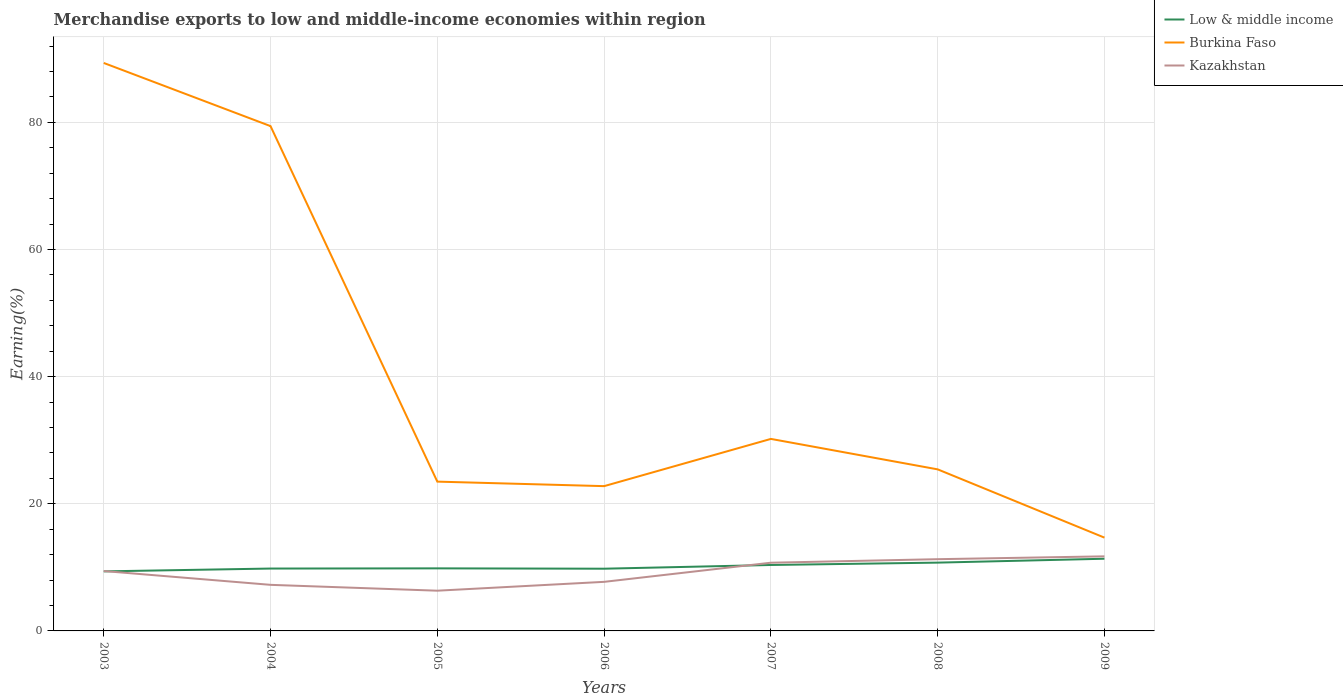Across all years, what is the maximum percentage of amount earned from merchandise exports in Burkina Faso?
Give a very brief answer. 14.67. In which year was the percentage of amount earned from merchandise exports in Low & middle income maximum?
Your answer should be compact. 2003. What is the total percentage of amount earned from merchandise exports in Burkina Faso in the graph?
Your answer should be very brief. 4.79. What is the difference between the highest and the second highest percentage of amount earned from merchandise exports in Low & middle income?
Your answer should be very brief. 1.99. What is the difference between the highest and the lowest percentage of amount earned from merchandise exports in Burkina Faso?
Your response must be concise. 2. Is the percentage of amount earned from merchandise exports in Burkina Faso strictly greater than the percentage of amount earned from merchandise exports in Low & middle income over the years?
Your response must be concise. No. How many lines are there?
Your response must be concise. 3. What is the difference between two consecutive major ticks on the Y-axis?
Your response must be concise. 20. Are the values on the major ticks of Y-axis written in scientific E-notation?
Ensure brevity in your answer.  No. Where does the legend appear in the graph?
Make the answer very short. Top right. How are the legend labels stacked?
Keep it short and to the point. Vertical. What is the title of the graph?
Keep it short and to the point. Merchandise exports to low and middle-income economies within region. Does "Korea (Republic)" appear as one of the legend labels in the graph?
Provide a short and direct response. No. What is the label or title of the X-axis?
Offer a terse response. Years. What is the label or title of the Y-axis?
Provide a short and direct response. Earning(%). What is the Earning(%) in Low & middle income in 2003?
Offer a terse response. 9.37. What is the Earning(%) in Burkina Faso in 2003?
Your answer should be compact. 89.34. What is the Earning(%) in Kazakhstan in 2003?
Your answer should be compact. 9.42. What is the Earning(%) of Low & middle income in 2004?
Offer a terse response. 9.81. What is the Earning(%) in Burkina Faso in 2004?
Make the answer very short. 79.41. What is the Earning(%) in Kazakhstan in 2004?
Ensure brevity in your answer.  7.25. What is the Earning(%) of Low & middle income in 2005?
Provide a succinct answer. 9.84. What is the Earning(%) in Burkina Faso in 2005?
Offer a terse response. 23.48. What is the Earning(%) of Kazakhstan in 2005?
Offer a very short reply. 6.33. What is the Earning(%) in Low & middle income in 2006?
Offer a very short reply. 9.79. What is the Earning(%) of Burkina Faso in 2006?
Your answer should be compact. 22.77. What is the Earning(%) of Kazakhstan in 2006?
Keep it short and to the point. 7.72. What is the Earning(%) in Low & middle income in 2007?
Your answer should be very brief. 10.37. What is the Earning(%) of Burkina Faso in 2007?
Your response must be concise. 30.2. What is the Earning(%) of Kazakhstan in 2007?
Provide a short and direct response. 10.73. What is the Earning(%) of Low & middle income in 2008?
Give a very brief answer. 10.74. What is the Earning(%) in Burkina Faso in 2008?
Your answer should be compact. 25.41. What is the Earning(%) in Kazakhstan in 2008?
Give a very brief answer. 11.28. What is the Earning(%) of Low & middle income in 2009?
Your answer should be very brief. 11.35. What is the Earning(%) of Burkina Faso in 2009?
Give a very brief answer. 14.67. What is the Earning(%) in Kazakhstan in 2009?
Your response must be concise. 11.73. Across all years, what is the maximum Earning(%) of Low & middle income?
Your response must be concise. 11.35. Across all years, what is the maximum Earning(%) in Burkina Faso?
Your answer should be compact. 89.34. Across all years, what is the maximum Earning(%) of Kazakhstan?
Your answer should be very brief. 11.73. Across all years, what is the minimum Earning(%) in Low & middle income?
Your response must be concise. 9.37. Across all years, what is the minimum Earning(%) in Burkina Faso?
Offer a terse response. 14.67. Across all years, what is the minimum Earning(%) in Kazakhstan?
Provide a short and direct response. 6.33. What is the total Earning(%) in Low & middle income in the graph?
Your answer should be compact. 71.28. What is the total Earning(%) of Burkina Faso in the graph?
Provide a succinct answer. 285.3. What is the total Earning(%) in Kazakhstan in the graph?
Give a very brief answer. 64.46. What is the difference between the Earning(%) in Low & middle income in 2003 and that in 2004?
Offer a terse response. -0.44. What is the difference between the Earning(%) of Burkina Faso in 2003 and that in 2004?
Ensure brevity in your answer.  9.93. What is the difference between the Earning(%) in Kazakhstan in 2003 and that in 2004?
Your answer should be very brief. 2.17. What is the difference between the Earning(%) of Low & middle income in 2003 and that in 2005?
Offer a terse response. -0.47. What is the difference between the Earning(%) of Burkina Faso in 2003 and that in 2005?
Your response must be concise. 65.86. What is the difference between the Earning(%) of Kazakhstan in 2003 and that in 2005?
Your response must be concise. 3.09. What is the difference between the Earning(%) in Low & middle income in 2003 and that in 2006?
Give a very brief answer. -0.42. What is the difference between the Earning(%) in Burkina Faso in 2003 and that in 2006?
Your response must be concise. 66.57. What is the difference between the Earning(%) in Kazakhstan in 2003 and that in 2006?
Make the answer very short. 1.7. What is the difference between the Earning(%) of Low & middle income in 2003 and that in 2007?
Offer a very short reply. -1.01. What is the difference between the Earning(%) in Burkina Faso in 2003 and that in 2007?
Provide a short and direct response. 59.14. What is the difference between the Earning(%) in Kazakhstan in 2003 and that in 2007?
Ensure brevity in your answer.  -1.31. What is the difference between the Earning(%) of Low & middle income in 2003 and that in 2008?
Keep it short and to the point. -1.38. What is the difference between the Earning(%) in Burkina Faso in 2003 and that in 2008?
Offer a very short reply. 63.92. What is the difference between the Earning(%) of Kazakhstan in 2003 and that in 2008?
Provide a short and direct response. -1.86. What is the difference between the Earning(%) of Low & middle income in 2003 and that in 2009?
Provide a short and direct response. -1.99. What is the difference between the Earning(%) in Burkina Faso in 2003 and that in 2009?
Make the answer very short. 74.66. What is the difference between the Earning(%) in Kazakhstan in 2003 and that in 2009?
Ensure brevity in your answer.  -2.31. What is the difference between the Earning(%) of Low & middle income in 2004 and that in 2005?
Your response must be concise. -0.03. What is the difference between the Earning(%) of Burkina Faso in 2004 and that in 2005?
Offer a terse response. 55.92. What is the difference between the Earning(%) in Kazakhstan in 2004 and that in 2005?
Provide a short and direct response. 0.92. What is the difference between the Earning(%) in Low & middle income in 2004 and that in 2006?
Your answer should be compact. 0.02. What is the difference between the Earning(%) of Burkina Faso in 2004 and that in 2006?
Offer a very short reply. 56.63. What is the difference between the Earning(%) in Kazakhstan in 2004 and that in 2006?
Offer a terse response. -0.47. What is the difference between the Earning(%) of Low & middle income in 2004 and that in 2007?
Ensure brevity in your answer.  -0.56. What is the difference between the Earning(%) of Burkina Faso in 2004 and that in 2007?
Provide a short and direct response. 49.2. What is the difference between the Earning(%) of Kazakhstan in 2004 and that in 2007?
Your response must be concise. -3.48. What is the difference between the Earning(%) of Low & middle income in 2004 and that in 2008?
Offer a terse response. -0.93. What is the difference between the Earning(%) in Burkina Faso in 2004 and that in 2008?
Your response must be concise. 53.99. What is the difference between the Earning(%) of Kazakhstan in 2004 and that in 2008?
Ensure brevity in your answer.  -4.04. What is the difference between the Earning(%) in Low & middle income in 2004 and that in 2009?
Provide a short and direct response. -1.54. What is the difference between the Earning(%) in Burkina Faso in 2004 and that in 2009?
Keep it short and to the point. 64.73. What is the difference between the Earning(%) of Kazakhstan in 2004 and that in 2009?
Give a very brief answer. -4.48. What is the difference between the Earning(%) of Low & middle income in 2005 and that in 2006?
Offer a very short reply. 0.05. What is the difference between the Earning(%) of Burkina Faso in 2005 and that in 2006?
Give a very brief answer. 0.71. What is the difference between the Earning(%) in Kazakhstan in 2005 and that in 2006?
Offer a very short reply. -1.39. What is the difference between the Earning(%) of Low & middle income in 2005 and that in 2007?
Your response must be concise. -0.53. What is the difference between the Earning(%) of Burkina Faso in 2005 and that in 2007?
Provide a short and direct response. -6.72. What is the difference between the Earning(%) in Kazakhstan in 2005 and that in 2007?
Provide a short and direct response. -4.4. What is the difference between the Earning(%) in Low & middle income in 2005 and that in 2008?
Ensure brevity in your answer.  -0.9. What is the difference between the Earning(%) of Burkina Faso in 2005 and that in 2008?
Ensure brevity in your answer.  -1.93. What is the difference between the Earning(%) of Kazakhstan in 2005 and that in 2008?
Provide a short and direct response. -4.96. What is the difference between the Earning(%) of Low & middle income in 2005 and that in 2009?
Your response must be concise. -1.51. What is the difference between the Earning(%) in Burkina Faso in 2005 and that in 2009?
Offer a very short reply. 8.81. What is the difference between the Earning(%) of Kazakhstan in 2005 and that in 2009?
Give a very brief answer. -5.4. What is the difference between the Earning(%) of Low & middle income in 2006 and that in 2007?
Your answer should be compact. -0.59. What is the difference between the Earning(%) of Burkina Faso in 2006 and that in 2007?
Your answer should be very brief. -7.43. What is the difference between the Earning(%) in Kazakhstan in 2006 and that in 2007?
Make the answer very short. -3.01. What is the difference between the Earning(%) of Low & middle income in 2006 and that in 2008?
Your answer should be very brief. -0.96. What is the difference between the Earning(%) of Burkina Faso in 2006 and that in 2008?
Your answer should be very brief. -2.64. What is the difference between the Earning(%) in Kazakhstan in 2006 and that in 2008?
Your response must be concise. -3.56. What is the difference between the Earning(%) in Low & middle income in 2006 and that in 2009?
Keep it short and to the point. -1.57. What is the difference between the Earning(%) in Burkina Faso in 2006 and that in 2009?
Provide a short and direct response. 8.1. What is the difference between the Earning(%) of Kazakhstan in 2006 and that in 2009?
Give a very brief answer. -4.01. What is the difference between the Earning(%) of Low & middle income in 2007 and that in 2008?
Offer a very short reply. -0.37. What is the difference between the Earning(%) of Burkina Faso in 2007 and that in 2008?
Provide a short and direct response. 4.79. What is the difference between the Earning(%) in Kazakhstan in 2007 and that in 2008?
Give a very brief answer. -0.55. What is the difference between the Earning(%) in Low & middle income in 2007 and that in 2009?
Provide a short and direct response. -0.98. What is the difference between the Earning(%) of Burkina Faso in 2007 and that in 2009?
Offer a very short reply. 15.53. What is the difference between the Earning(%) in Kazakhstan in 2007 and that in 2009?
Your answer should be very brief. -1. What is the difference between the Earning(%) of Low & middle income in 2008 and that in 2009?
Make the answer very short. -0.61. What is the difference between the Earning(%) of Burkina Faso in 2008 and that in 2009?
Keep it short and to the point. 10.74. What is the difference between the Earning(%) of Kazakhstan in 2008 and that in 2009?
Offer a terse response. -0.45. What is the difference between the Earning(%) of Low & middle income in 2003 and the Earning(%) of Burkina Faso in 2004?
Ensure brevity in your answer.  -70.04. What is the difference between the Earning(%) in Low & middle income in 2003 and the Earning(%) in Kazakhstan in 2004?
Your response must be concise. 2.12. What is the difference between the Earning(%) in Burkina Faso in 2003 and the Earning(%) in Kazakhstan in 2004?
Your answer should be compact. 82.09. What is the difference between the Earning(%) of Low & middle income in 2003 and the Earning(%) of Burkina Faso in 2005?
Ensure brevity in your answer.  -14.12. What is the difference between the Earning(%) of Low & middle income in 2003 and the Earning(%) of Kazakhstan in 2005?
Offer a terse response. 3.04. What is the difference between the Earning(%) in Burkina Faso in 2003 and the Earning(%) in Kazakhstan in 2005?
Your answer should be very brief. 83.01. What is the difference between the Earning(%) of Low & middle income in 2003 and the Earning(%) of Burkina Faso in 2006?
Provide a succinct answer. -13.41. What is the difference between the Earning(%) of Low & middle income in 2003 and the Earning(%) of Kazakhstan in 2006?
Provide a short and direct response. 1.65. What is the difference between the Earning(%) of Burkina Faso in 2003 and the Earning(%) of Kazakhstan in 2006?
Keep it short and to the point. 81.62. What is the difference between the Earning(%) in Low & middle income in 2003 and the Earning(%) in Burkina Faso in 2007?
Give a very brief answer. -20.84. What is the difference between the Earning(%) of Low & middle income in 2003 and the Earning(%) of Kazakhstan in 2007?
Your answer should be very brief. -1.36. What is the difference between the Earning(%) of Burkina Faso in 2003 and the Earning(%) of Kazakhstan in 2007?
Your response must be concise. 78.61. What is the difference between the Earning(%) of Low & middle income in 2003 and the Earning(%) of Burkina Faso in 2008?
Offer a very short reply. -16.05. What is the difference between the Earning(%) in Low & middle income in 2003 and the Earning(%) in Kazakhstan in 2008?
Offer a very short reply. -1.92. What is the difference between the Earning(%) of Burkina Faso in 2003 and the Earning(%) of Kazakhstan in 2008?
Provide a succinct answer. 78.06. What is the difference between the Earning(%) in Low & middle income in 2003 and the Earning(%) in Burkina Faso in 2009?
Your answer should be very brief. -5.31. What is the difference between the Earning(%) in Low & middle income in 2003 and the Earning(%) in Kazakhstan in 2009?
Your answer should be compact. -2.36. What is the difference between the Earning(%) in Burkina Faso in 2003 and the Earning(%) in Kazakhstan in 2009?
Your answer should be compact. 77.61. What is the difference between the Earning(%) of Low & middle income in 2004 and the Earning(%) of Burkina Faso in 2005?
Your answer should be compact. -13.67. What is the difference between the Earning(%) in Low & middle income in 2004 and the Earning(%) in Kazakhstan in 2005?
Your response must be concise. 3.48. What is the difference between the Earning(%) in Burkina Faso in 2004 and the Earning(%) in Kazakhstan in 2005?
Your response must be concise. 73.08. What is the difference between the Earning(%) in Low & middle income in 2004 and the Earning(%) in Burkina Faso in 2006?
Provide a short and direct response. -12.96. What is the difference between the Earning(%) of Low & middle income in 2004 and the Earning(%) of Kazakhstan in 2006?
Give a very brief answer. 2.09. What is the difference between the Earning(%) in Burkina Faso in 2004 and the Earning(%) in Kazakhstan in 2006?
Give a very brief answer. 71.69. What is the difference between the Earning(%) in Low & middle income in 2004 and the Earning(%) in Burkina Faso in 2007?
Your answer should be compact. -20.39. What is the difference between the Earning(%) of Low & middle income in 2004 and the Earning(%) of Kazakhstan in 2007?
Give a very brief answer. -0.92. What is the difference between the Earning(%) of Burkina Faso in 2004 and the Earning(%) of Kazakhstan in 2007?
Keep it short and to the point. 68.68. What is the difference between the Earning(%) in Low & middle income in 2004 and the Earning(%) in Burkina Faso in 2008?
Provide a succinct answer. -15.6. What is the difference between the Earning(%) in Low & middle income in 2004 and the Earning(%) in Kazakhstan in 2008?
Provide a short and direct response. -1.47. What is the difference between the Earning(%) in Burkina Faso in 2004 and the Earning(%) in Kazakhstan in 2008?
Ensure brevity in your answer.  68.12. What is the difference between the Earning(%) of Low & middle income in 2004 and the Earning(%) of Burkina Faso in 2009?
Make the answer very short. -4.86. What is the difference between the Earning(%) of Low & middle income in 2004 and the Earning(%) of Kazakhstan in 2009?
Make the answer very short. -1.92. What is the difference between the Earning(%) of Burkina Faso in 2004 and the Earning(%) of Kazakhstan in 2009?
Give a very brief answer. 67.67. What is the difference between the Earning(%) in Low & middle income in 2005 and the Earning(%) in Burkina Faso in 2006?
Your response must be concise. -12.93. What is the difference between the Earning(%) of Low & middle income in 2005 and the Earning(%) of Kazakhstan in 2006?
Your response must be concise. 2.12. What is the difference between the Earning(%) in Burkina Faso in 2005 and the Earning(%) in Kazakhstan in 2006?
Offer a terse response. 15.77. What is the difference between the Earning(%) of Low & middle income in 2005 and the Earning(%) of Burkina Faso in 2007?
Make the answer very short. -20.36. What is the difference between the Earning(%) of Low & middle income in 2005 and the Earning(%) of Kazakhstan in 2007?
Give a very brief answer. -0.89. What is the difference between the Earning(%) of Burkina Faso in 2005 and the Earning(%) of Kazakhstan in 2007?
Offer a very short reply. 12.76. What is the difference between the Earning(%) of Low & middle income in 2005 and the Earning(%) of Burkina Faso in 2008?
Give a very brief answer. -15.57. What is the difference between the Earning(%) in Low & middle income in 2005 and the Earning(%) in Kazakhstan in 2008?
Make the answer very short. -1.44. What is the difference between the Earning(%) in Burkina Faso in 2005 and the Earning(%) in Kazakhstan in 2008?
Your answer should be compact. 12.2. What is the difference between the Earning(%) in Low & middle income in 2005 and the Earning(%) in Burkina Faso in 2009?
Ensure brevity in your answer.  -4.83. What is the difference between the Earning(%) of Low & middle income in 2005 and the Earning(%) of Kazakhstan in 2009?
Provide a succinct answer. -1.89. What is the difference between the Earning(%) in Burkina Faso in 2005 and the Earning(%) in Kazakhstan in 2009?
Your answer should be very brief. 11.75. What is the difference between the Earning(%) of Low & middle income in 2006 and the Earning(%) of Burkina Faso in 2007?
Your answer should be compact. -20.42. What is the difference between the Earning(%) of Low & middle income in 2006 and the Earning(%) of Kazakhstan in 2007?
Provide a short and direct response. -0.94. What is the difference between the Earning(%) in Burkina Faso in 2006 and the Earning(%) in Kazakhstan in 2007?
Provide a succinct answer. 12.04. What is the difference between the Earning(%) in Low & middle income in 2006 and the Earning(%) in Burkina Faso in 2008?
Give a very brief answer. -15.63. What is the difference between the Earning(%) in Low & middle income in 2006 and the Earning(%) in Kazakhstan in 2008?
Offer a very short reply. -1.5. What is the difference between the Earning(%) of Burkina Faso in 2006 and the Earning(%) of Kazakhstan in 2008?
Offer a very short reply. 11.49. What is the difference between the Earning(%) in Low & middle income in 2006 and the Earning(%) in Burkina Faso in 2009?
Give a very brief answer. -4.89. What is the difference between the Earning(%) in Low & middle income in 2006 and the Earning(%) in Kazakhstan in 2009?
Your answer should be very brief. -1.94. What is the difference between the Earning(%) in Burkina Faso in 2006 and the Earning(%) in Kazakhstan in 2009?
Keep it short and to the point. 11.04. What is the difference between the Earning(%) in Low & middle income in 2007 and the Earning(%) in Burkina Faso in 2008?
Make the answer very short. -15.04. What is the difference between the Earning(%) of Low & middle income in 2007 and the Earning(%) of Kazakhstan in 2008?
Your response must be concise. -0.91. What is the difference between the Earning(%) of Burkina Faso in 2007 and the Earning(%) of Kazakhstan in 2008?
Give a very brief answer. 18.92. What is the difference between the Earning(%) of Low & middle income in 2007 and the Earning(%) of Burkina Faso in 2009?
Provide a short and direct response. -4.3. What is the difference between the Earning(%) of Low & middle income in 2007 and the Earning(%) of Kazakhstan in 2009?
Your answer should be very brief. -1.36. What is the difference between the Earning(%) of Burkina Faso in 2007 and the Earning(%) of Kazakhstan in 2009?
Make the answer very short. 18.47. What is the difference between the Earning(%) in Low & middle income in 2008 and the Earning(%) in Burkina Faso in 2009?
Your response must be concise. -3.93. What is the difference between the Earning(%) of Low & middle income in 2008 and the Earning(%) of Kazakhstan in 2009?
Your response must be concise. -0.99. What is the difference between the Earning(%) in Burkina Faso in 2008 and the Earning(%) in Kazakhstan in 2009?
Provide a succinct answer. 13.68. What is the average Earning(%) in Low & middle income per year?
Keep it short and to the point. 10.18. What is the average Earning(%) of Burkina Faso per year?
Keep it short and to the point. 40.76. What is the average Earning(%) in Kazakhstan per year?
Make the answer very short. 9.21. In the year 2003, what is the difference between the Earning(%) in Low & middle income and Earning(%) in Burkina Faso?
Offer a very short reply. -79.97. In the year 2003, what is the difference between the Earning(%) of Low & middle income and Earning(%) of Kazakhstan?
Your answer should be compact. -0.05. In the year 2003, what is the difference between the Earning(%) of Burkina Faso and Earning(%) of Kazakhstan?
Keep it short and to the point. 79.92. In the year 2004, what is the difference between the Earning(%) of Low & middle income and Earning(%) of Burkina Faso?
Provide a short and direct response. -69.59. In the year 2004, what is the difference between the Earning(%) in Low & middle income and Earning(%) in Kazakhstan?
Offer a very short reply. 2.56. In the year 2004, what is the difference between the Earning(%) in Burkina Faso and Earning(%) in Kazakhstan?
Provide a short and direct response. 72.16. In the year 2005, what is the difference between the Earning(%) in Low & middle income and Earning(%) in Burkina Faso?
Your answer should be compact. -13.64. In the year 2005, what is the difference between the Earning(%) of Low & middle income and Earning(%) of Kazakhstan?
Make the answer very short. 3.51. In the year 2005, what is the difference between the Earning(%) in Burkina Faso and Earning(%) in Kazakhstan?
Your answer should be compact. 17.16. In the year 2006, what is the difference between the Earning(%) of Low & middle income and Earning(%) of Burkina Faso?
Your answer should be very brief. -12.99. In the year 2006, what is the difference between the Earning(%) of Low & middle income and Earning(%) of Kazakhstan?
Ensure brevity in your answer.  2.07. In the year 2006, what is the difference between the Earning(%) of Burkina Faso and Earning(%) of Kazakhstan?
Your response must be concise. 15.05. In the year 2007, what is the difference between the Earning(%) of Low & middle income and Earning(%) of Burkina Faso?
Make the answer very short. -19.83. In the year 2007, what is the difference between the Earning(%) in Low & middle income and Earning(%) in Kazakhstan?
Make the answer very short. -0.36. In the year 2007, what is the difference between the Earning(%) of Burkina Faso and Earning(%) of Kazakhstan?
Make the answer very short. 19.47. In the year 2008, what is the difference between the Earning(%) in Low & middle income and Earning(%) in Burkina Faso?
Keep it short and to the point. -14.67. In the year 2008, what is the difference between the Earning(%) of Low & middle income and Earning(%) of Kazakhstan?
Give a very brief answer. -0.54. In the year 2008, what is the difference between the Earning(%) of Burkina Faso and Earning(%) of Kazakhstan?
Give a very brief answer. 14.13. In the year 2009, what is the difference between the Earning(%) of Low & middle income and Earning(%) of Burkina Faso?
Offer a very short reply. -3.32. In the year 2009, what is the difference between the Earning(%) of Low & middle income and Earning(%) of Kazakhstan?
Offer a very short reply. -0.38. In the year 2009, what is the difference between the Earning(%) of Burkina Faso and Earning(%) of Kazakhstan?
Make the answer very short. 2.94. What is the ratio of the Earning(%) of Low & middle income in 2003 to that in 2004?
Keep it short and to the point. 0.95. What is the ratio of the Earning(%) in Burkina Faso in 2003 to that in 2004?
Offer a very short reply. 1.13. What is the ratio of the Earning(%) in Kazakhstan in 2003 to that in 2004?
Your response must be concise. 1.3. What is the ratio of the Earning(%) in Low & middle income in 2003 to that in 2005?
Provide a short and direct response. 0.95. What is the ratio of the Earning(%) of Burkina Faso in 2003 to that in 2005?
Offer a terse response. 3.8. What is the ratio of the Earning(%) of Kazakhstan in 2003 to that in 2005?
Give a very brief answer. 1.49. What is the ratio of the Earning(%) of Low & middle income in 2003 to that in 2006?
Make the answer very short. 0.96. What is the ratio of the Earning(%) of Burkina Faso in 2003 to that in 2006?
Offer a very short reply. 3.92. What is the ratio of the Earning(%) in Kazakhstan in 2003 to that in 2006?
Offer a terse response. 1.22. What is the ratio of the Earning(%) of Low & middle income in 2003 to that in 2007?
Your answer should be very brief. 0.9. What is the ratio of the Earning(%) in Burkina Faso in 2003 to that in 2007?
Your response must be concise. 2.96. What is the ratio of the Earning(%) of Kazakhstan in 2003 to that in 2007?
Your answer should be compact. 0.88. What is the ratio of the Earning(%) in Low & middle income in 2003 to that in 2008?
Your answer should be compact. 0.87. What is the ratio of the Earning(%) of Burkina Faso in 2003 to that in 2008?
Offer a terse response. 3.52. What is the ratio of the Earning(%) in Kazakhstan in 2003 to that in 2008?
Your answer should be very brief. 0.83. What is the ratio of the Earning(%) in Low & middle income in 2003 to that in 2009?
Your answer should be compact. 0.82. What is the ratio of the Earning(%) in Burkina Faso in 2003 to that in 2009?
Keep it short and to the point. 6.09. What is the ratio of the Earning(%) of Kazakhstan in 2003 to that in 2009?
Provide a succinct answer. 0.8. What is the ratio of the Earning(%) of Low & middle income in 2004 to that in 2005?
Keep it short and to the point. 1. What is the ratio of the Earning(%) of Burkina Faso in 2004 to that in 2005?
Your response must be concise. 3.38. What is the ratio of the Earning(%) in Kazakhstan in 2004 to that in 2005?
Keep it short and to the point. 1.15. What is the ratio of the Earning(%) of Burkina Faso in 2004 to that in 2006?
Give a very brief answer. 3.49. What is the ratio of the Earning(%) in Kazakhstan in 2004 to that in 2006?
Offer a terse response. 0.94. What is the ratio of the Earning(%) in Low & middle income in 2004 to that in 2007?
Ensure brevity in your answer.  0.95. What is the ratio of the Earning(%) of Burkina Faso in 2004 to that in 2007?
Give a very brief answer. 2.63. What is the ratio of the Earning(%) of Kazakhstan in 2004 to that in 2007?
Keep it short and to the point. 0.68. What is the ratio of the Earning(%) of Low & middle income in 2004 to that in 2008?
Provide a succinct answer. 0.91. What is the ratio of the Earning(%) of Burkina Faso in 2004 to that in 2008?
Ensure brevity in your answer.  3.12. What is the ratio of the Earning(%) in Kazakhstan in 2004 to that in 2008?
Keep it short and to the point. 0.64. What is the ratio of the Earning(%) in Low & middle income in 2004 to that in 2009?
Your answer should be very brief. 0.86. What is the ratio of the Earning(%) in Burkina Faso in 2004 to that in 2009?
Your answer should be very brief. 5.41. What is the ratio of the Earning(%) in Kazakhstan in 2004 to that in 2009?
Provide a short and direct response. 0.62. What is the ratio of the Earning(%) in Low & middle income in 2005 to that in 2006?
Offer a very short reply. 1.01. What is the ratio of the Earning(%) in Burkina Faso in 2005 to that in 2006?
Offer a terse response. 1.03. What is the ratio of the Earning(%) of Kazakhstan in 2005 to that in 2006?
Your answer should be very brief. 0.82. What is the ratio of the Earning(%) of Low & middle income in 2005 to that in 2007?
Offer a terse response. 0.95. What is the ratio of the Earning(%) of Burkina Faso in 2005 to that in 2007?
Offer a very short reply. 0.78. What is the ratio of the Earning(%) in Kazakhstan in 2005 to that in 2007?
Your answer should be compact. 0.59. What is the ratio of the Earning(%) in Low & middle income in 2005 to that in 2008?
Your answer should be very brief. 0.92. What is the ratio of the Earning(%) of Burkina Faso in 2005 to that in 2008?
Offer a terse response. 0.92. What is the ratio of the Earning(%) of Kazakhstan in 2005 to that in 2008?
Provide a short and direct response. 0.56. What is the ratio of the Earning(%) in Low & middle income in 2005 to that in 2009?
Keep it short and to the point. 0.87. What is the ratio of the Earning(%) in Burkina Faso in 2005 to that in 2009?
Provide a short and direct response. 1.6. What is the ratio of the Earning(%) in Kazakhstan in 2005 to that in 2009?
Offer a very short reply. 0.54. What is the ratio of the Earning(%) in Low & middle income in 2006 to that in 2007?
Ensure brevity in your answer.  0.94. What is the ratio of the Earning(%) in Burkina Faso in 2006 to that in 2007?
Provide a short and direct response. 0.75. What is the ratio of the Earning(%) in Kazakhstan in 2006 to that in 2007?
Provide a short and direct response. 0.72. What is the ratio of the Earning(%) in Low & middle income in 2006 to that in 2008?
Your response must be concise. 0.91. What is the ratio of the Earning(%) of Burkina Faso in 2006 to that in 2008?
Offer a terse response. 0.9. What is the ratio of the Earning(%) in Kazakhstan in 2006 to that in 2008?
Your answer should be very brief. 0.68. What is the ratio of the Earning(%) in Low & middle income in 2006 to that in 2009?
Provide a short and direct response. 0.86. What is the ratio of the Earning(%) in Burkina Faso in 2006 to that in 2009?
Your response must be concise. 1.55. What is the ratio of the Earning(%) of Kazakhstan in 2006 to that in 2009?
Provide a short and direct response. 0.66. What is the ratio of the Earning(%) of Low & middle income in 2007 to that in 2008?
Your answer should be very brief. 0.97. What is the ratio of the Earning(%) of Burkina Faso in 2007 to that in 2008?
Ensure brevity in your answer.  1.19. What is the ratio of the Earning(%) of Kazakhstan in 2007 to that in 2008?
Ensure brevity in your answer.  0.95. What is the ratio of the Earning(%) of Low & middle income in 2007 to that in 2009?
Offer a very short reply. 0.91. What is the ratio of the Earning(%) of Burkina Faso in 2007 to that in 2009?
Make the answer very short. 2.06. What is the ratio of the Earning(%) in Kazakhstan in 2007 to that in 2009?
Offer a terse response. 0.91. What is the ratio of the Earning(%) in Low & middle income in 2008 to that in 2009?
Offer a very short reply. 0.95. What is the ratio of the Earning(%) of Burkina Faso in 2008 to that in 2009?
Make the answer very short. 1.73. What is the ratio of the Earning(%) in Kazakhstan in 2008 to that in 2009?
Your response must be concise. 0.96. What is the difference between the highest and the second highest Earning(%) of Low & middle income?
Keep it short and to the point. 0.61. What is the difference between the highest and the second highest Earning(%) of Burkina Faso?
Your answer should be compact. 9.93. What is the difference between the highest and the second highest Earning(%) in Kazakhstan?
Offer a very short reply. 0.45. What is the difference between the highest and the lowest Earning(%) in Low & middle income?
Your response must be concise. 1.99. What is the difference between the highest and the lowest Earning(%) of Burkina Faso?
Your answer should be very brief. 74.66. What is the difference between the highest and the lowest Earning(%) in Kazakhstan?
Your answer should be compact. 5.4. 